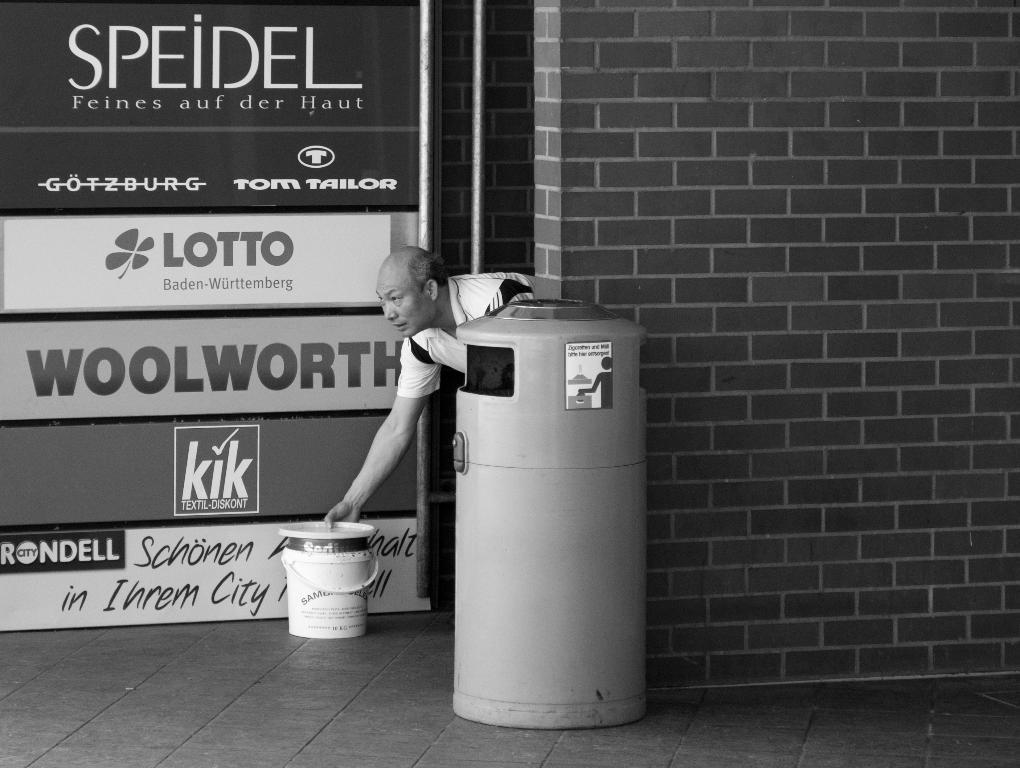<image>
Relay a brief, clear account of the picture shown. A man holding a bucket in front of a Woolworth sign. 